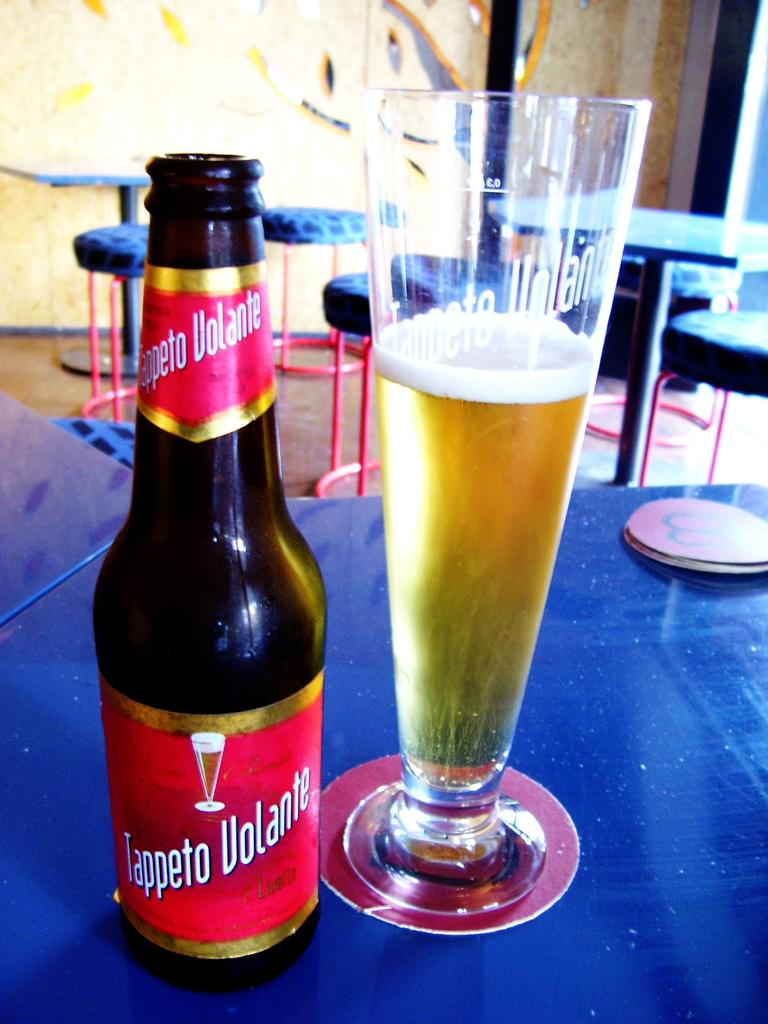<image>
Share a concise interpretation of the image provided. A bottle of tappeto volante that has a red label 